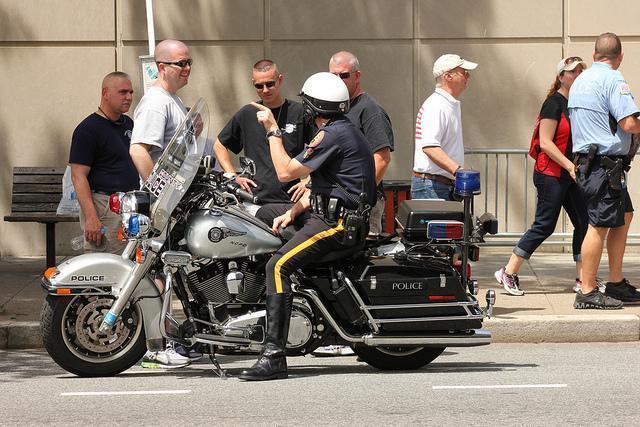How is the engine on this motorcycle cooled?
Indicate the correct response by choosing from the four available options to answer the question.
Options: Pressure, oil, air, water. Air. 